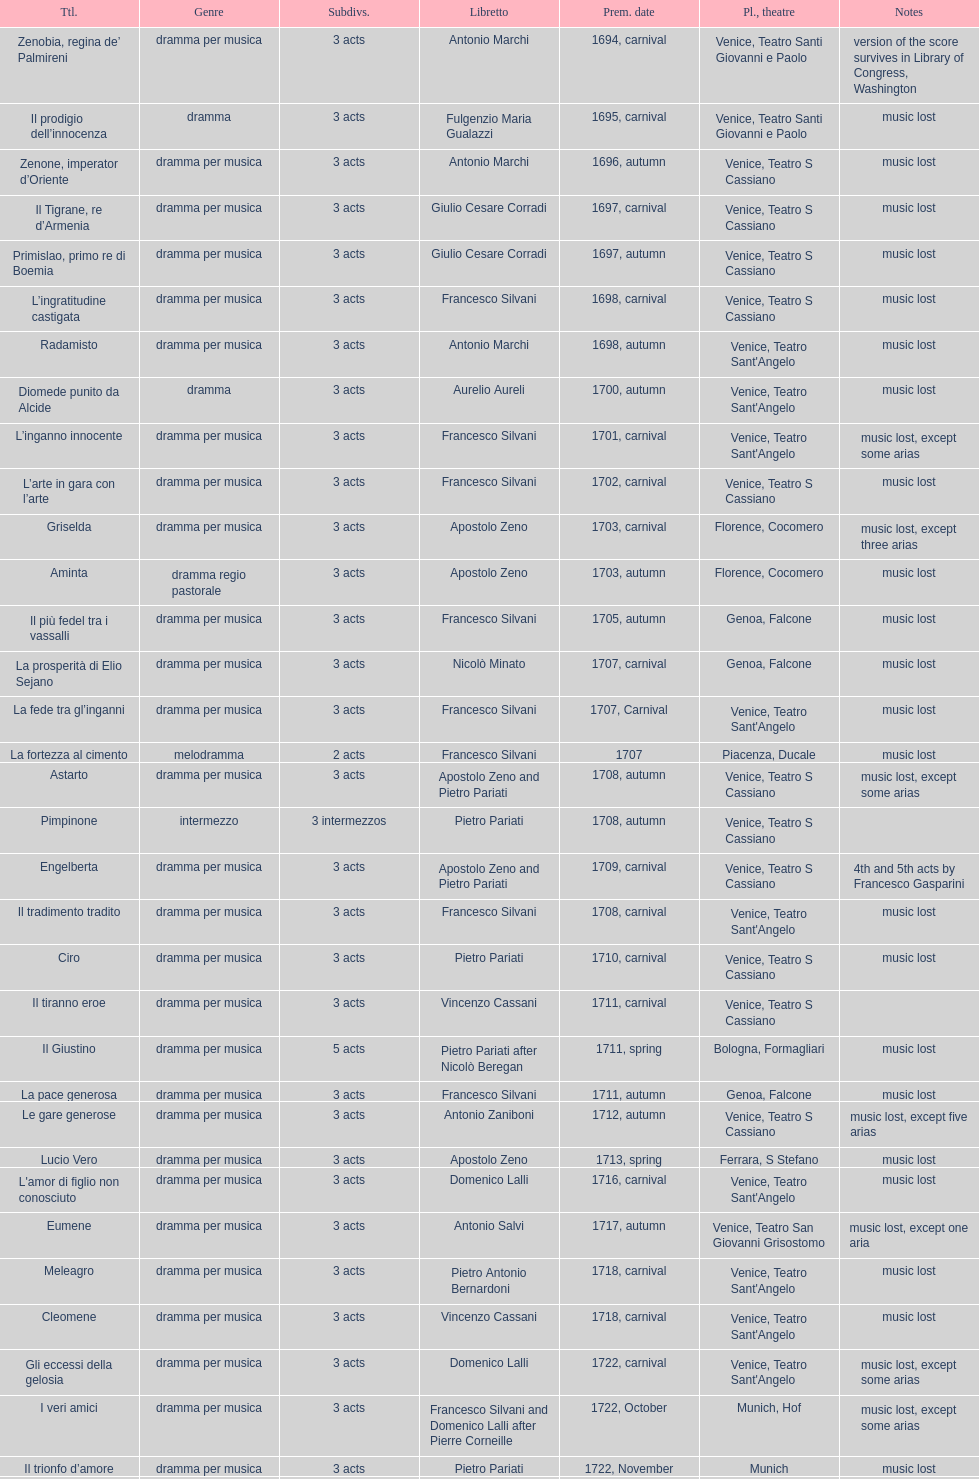L'inganno innocente premiered in 1701. what was the previous title released? Diomede punito da Alcide. 